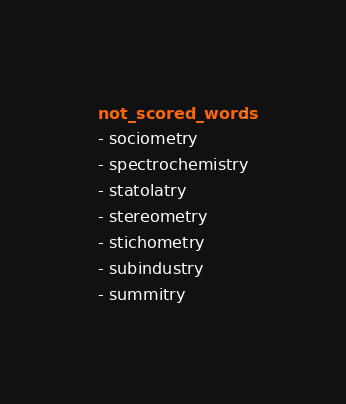Convert code to text. <code><loc_0><loc_0><loc_500><loc_500><_YAML_>not_scored_words:
- sociometry
- spectrochemistry
- statolatry
- stereometry
- stichometry
- subindustry
- summitry
</code> 